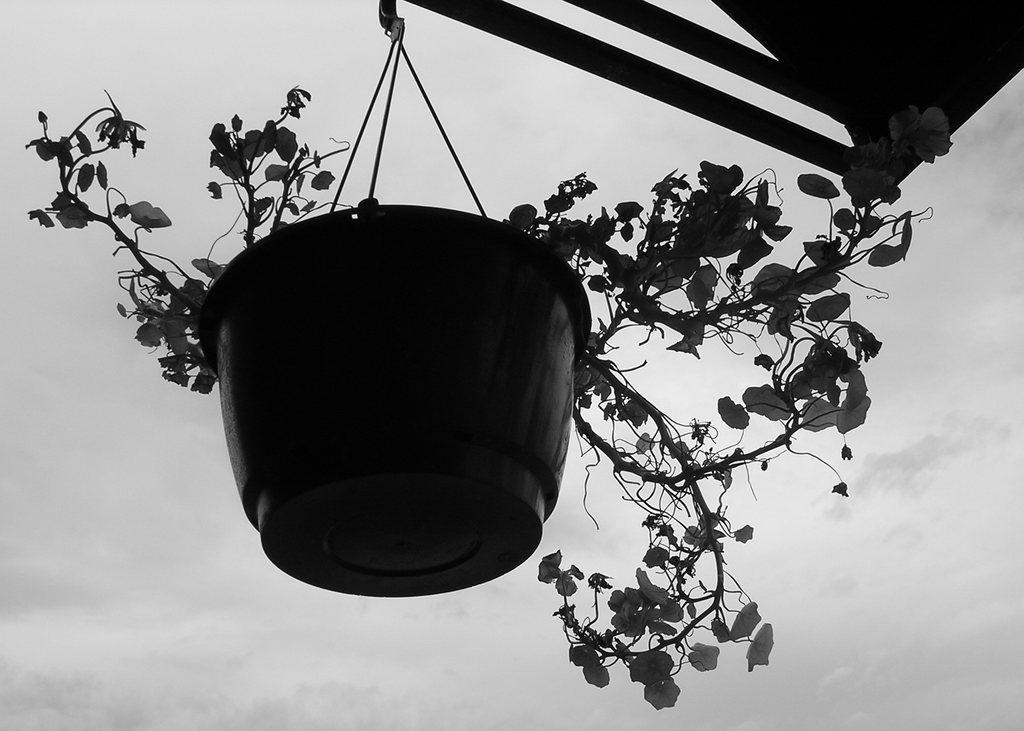Please provide a concise description of this image. In this picture we can see the plant pot, hanging on the shed. Behind there is a sky and clouds. 